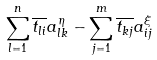<formula> <loc_0><loc_0><loc_500><loc_500>\sum _ { l = 1 } ^ { n } \overline { t _ { l i } } a ^ { \eta } _ { l k } - \sum _ { j = 1 } ^ { m } \overline { t _ { k j } } a ^ { \xi } _ { i j }</formula> 